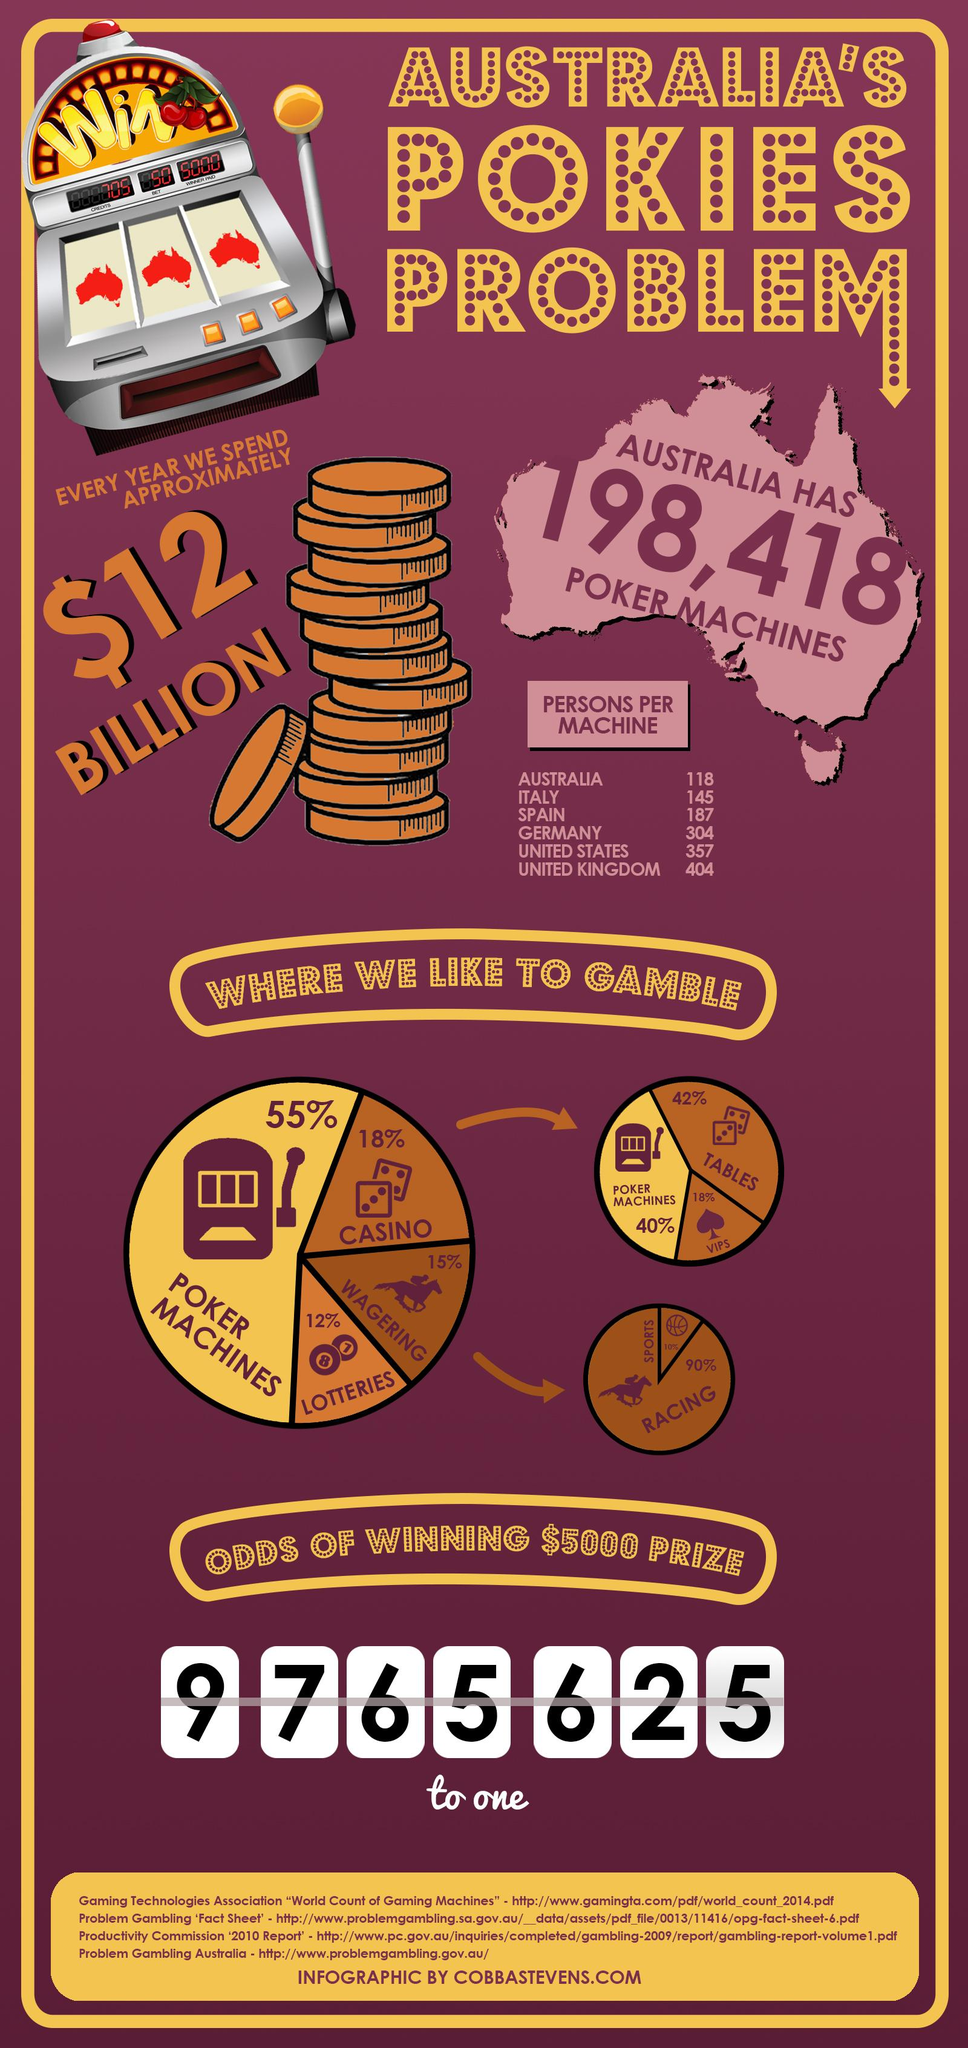Highlight a few significant elements in this photo. According to the list of countries with the highest number of poker machines per person, Spain is ranked third. The percentage difference in the number of people using poker machines and casinos is 37%. The second highest value listed in the table is 357. In Australia, the majority of people prefer to gamble on Poker Machines rather than in Casinos or through Lotteries. 